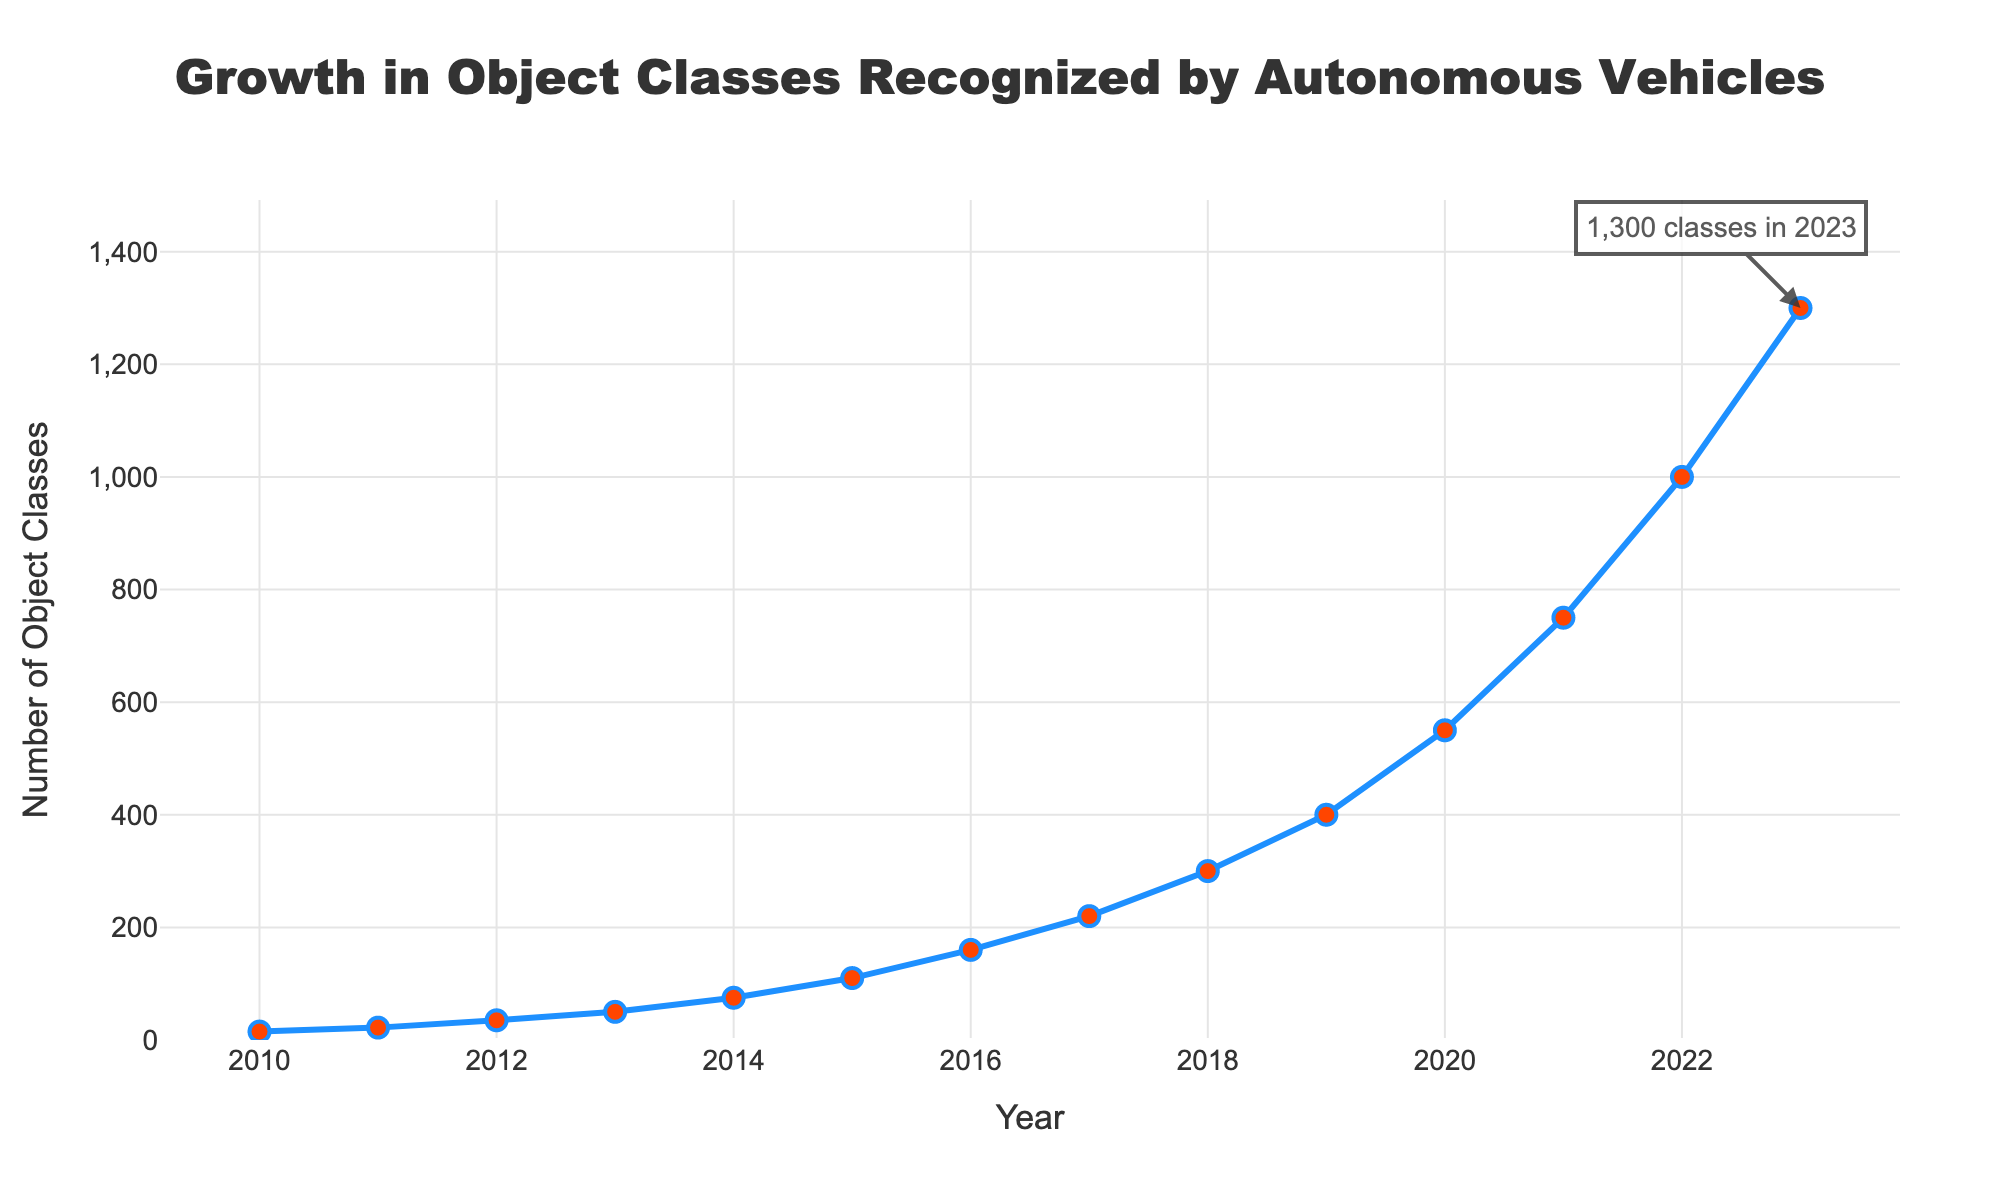What year experienced the greatest increase in the number of object classes recognized compared to the previous year? The greatest increase in the number of recognized object classes occurred between 2022 and 2023, where the increase was from 1000 to 1300. The increase is 300, which is the largest compared to any other year-to-year change.
Answer: 2023 How many object classes were recognized in 2012 and 2022 combined? In 2012, 35 object classes were recognized, and in 2022, 1000 object classes were recognized. The combined total is 35 + 1000 = 1035.
Answer: 1035 Between which years was there a bigger increase in the number of object classes recognized: between 2010 to 2015 or 2016 to 2021? From 2010 (15) to 2015 (110), the increase is 110 - 15 = 95. From 2016 (160) to 2021 (750), the increase is 750 - 160 = 590. Thus, the increase from 2016 to 2021 is much bigger.
Answer: 2016 to 2021 What is the average number of object classes recognized in the years 2020, 2021, 2022, and 2023? Add the number of object classes recognized in 2020 (550), 2021 (750), 2022 (1000), and 2023 (1300), which totals 550 + 750 + 1000 + 1300 = 3600. Divide by 4 to get the average: 3600 / 4 = 900.
Answer: 900 Which year shows an annotation and what information does it provide? The annotation is shown in the year 2023 and it provides information that 1,300 object classes were recognized in 2023.
Answer: 2023, 1300 classes What is the visual difference in how the data points are represented compared to the line connecting them? The data points are represented with red circular markers with blue borders, while the line connecting them is blue.
Answer: Red circular markers with blue borders; blue line In which year does the number of recognized object classes first exceed 300? The number first exceeds 300 in the year 2018, where 300 classes are recognized exactly. By 2019, 400 classes are recognized.
Answer: 2019 Which decade saw the most significant growth in the number of object classes recognized, and how can this be represented visually? The decade from 2013 to 2023 saw the most significant growth, increasing from 50 to 1300. Visually, this is represented by the steep slope of the line on the chart during this decade.
Answer: 2013 to 2023 